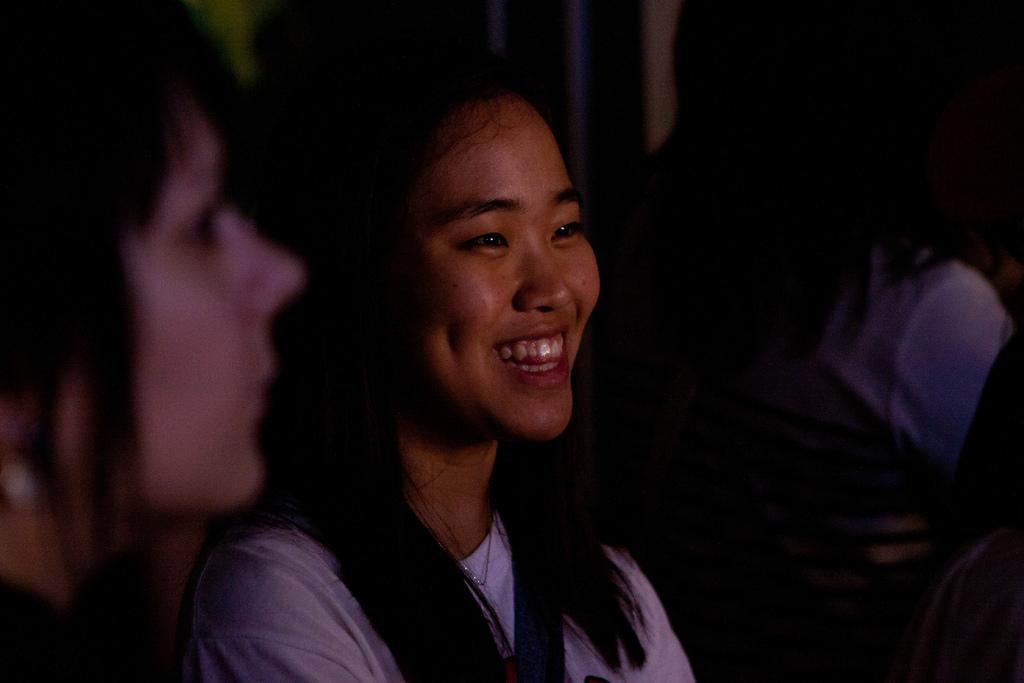Who is the main subject in the image? There is a lady in the center of the image. What is the lady doing in the image? The lady is smiling. Can you describe the background of the image? There are people in the background of the image. What type of water is visible in the lady's eye in the image? There is no water visible in the lady's eye in the image. What is the lady holding in her hand in the picture? The provided facts do not mention any object the lady is holding in her hand. 